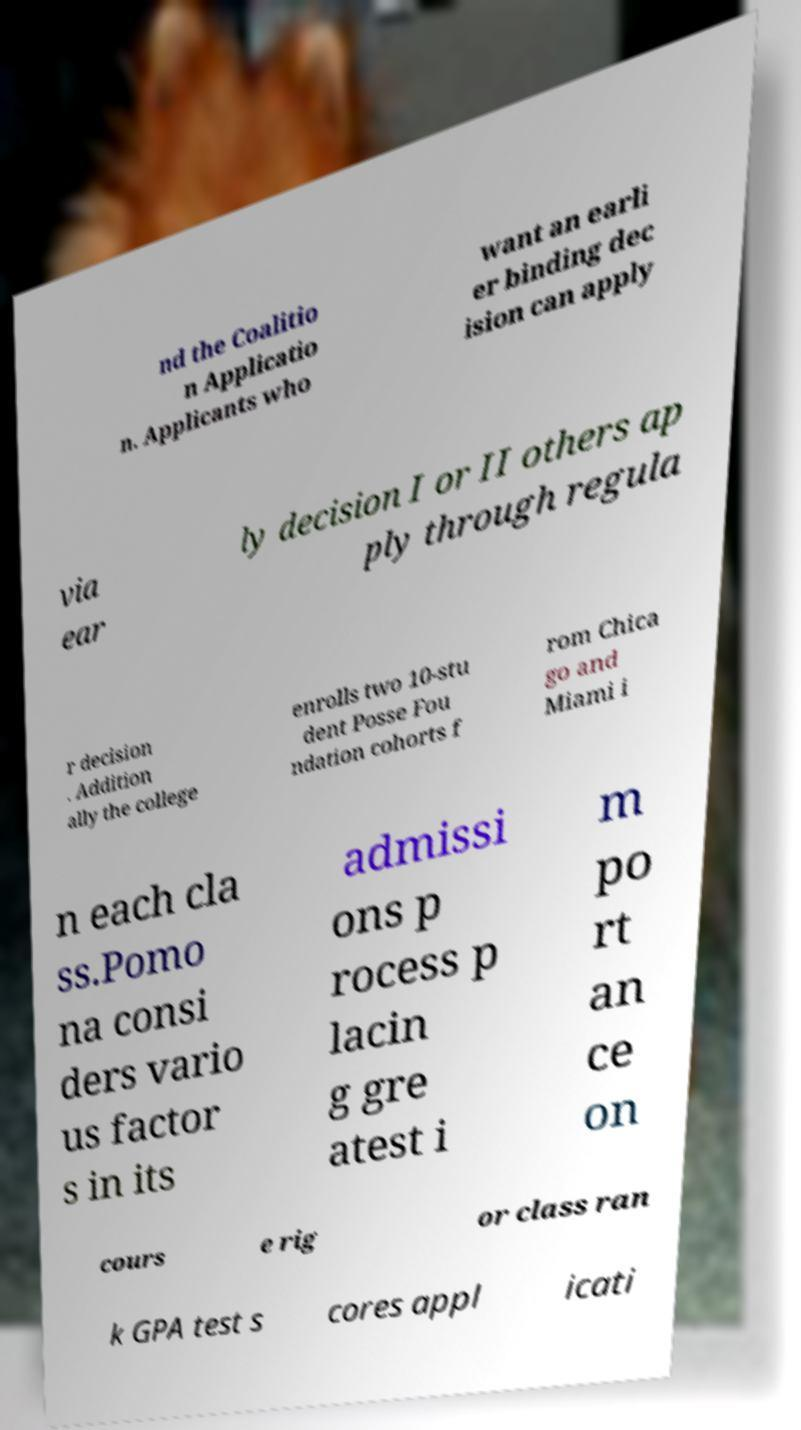Can you accurately transcribe the text from the provided image for me? nd the Coalitio n Applicatio n. Applicants who want an earli er binding dec ision can apply via ear ly decision I or II others ap ply through regula r decision . Addition ally the college enrolls two 10-stu dent Posse Fou ndation cohorts f rom Chica go and Miami i n each cla ss.Pomo na consi ders vario us factor s in its admissi ons p rocess p lacin g gre atest i m po rt an ce on cours e rig or class ran k GPA test s cores appl icati 